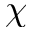Convert formula to latex. <formula><loc_0><loc_0><loc_500><loc_500>\chi</formula> 